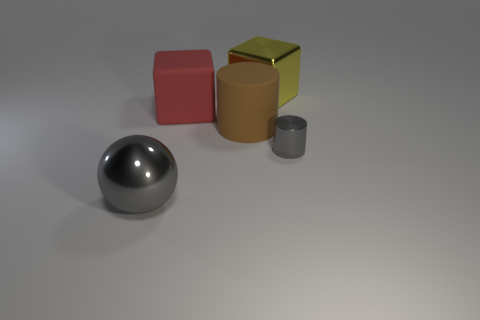Add 1 big gray metallic objects. How many objects exist? 6 Subtract all spheres. How many objects are left? 4 Subtract all gray cylinders. How many cylinders are left? 1 Subtract 1 cubes. How many cubes are left? 1 Subtract all yellow cylinders. How many red cubes are left? 1 Subtract all large yellow things. Subtract all cyan shiny spheres. How many objects are left? 4 Add 4 tiny objects. How many tiny objects are left? 5 Add 2 big cyan shiny balls. How many big cyan shiny balls exist? 2 Subtract 0 purple blocks. How many objects are left? 5 Subtract all gray cylinders. Subtract all green balls. How many cylinders are left? 1 